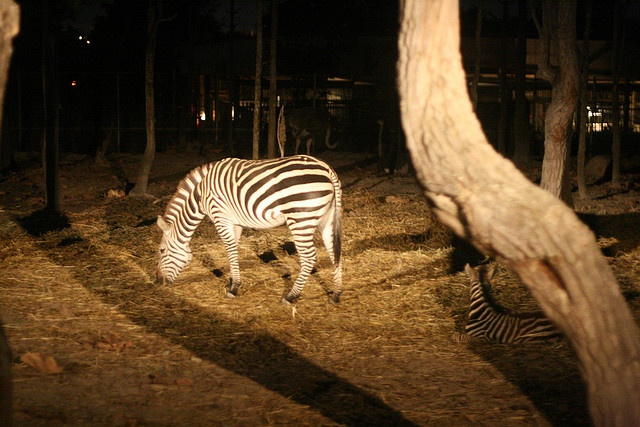Describe the objects in this image and their specific colors. I can see zebra in olive, lightyellow, tan, and gray tones and zebra in olive, black, and maroon tones in this image. 